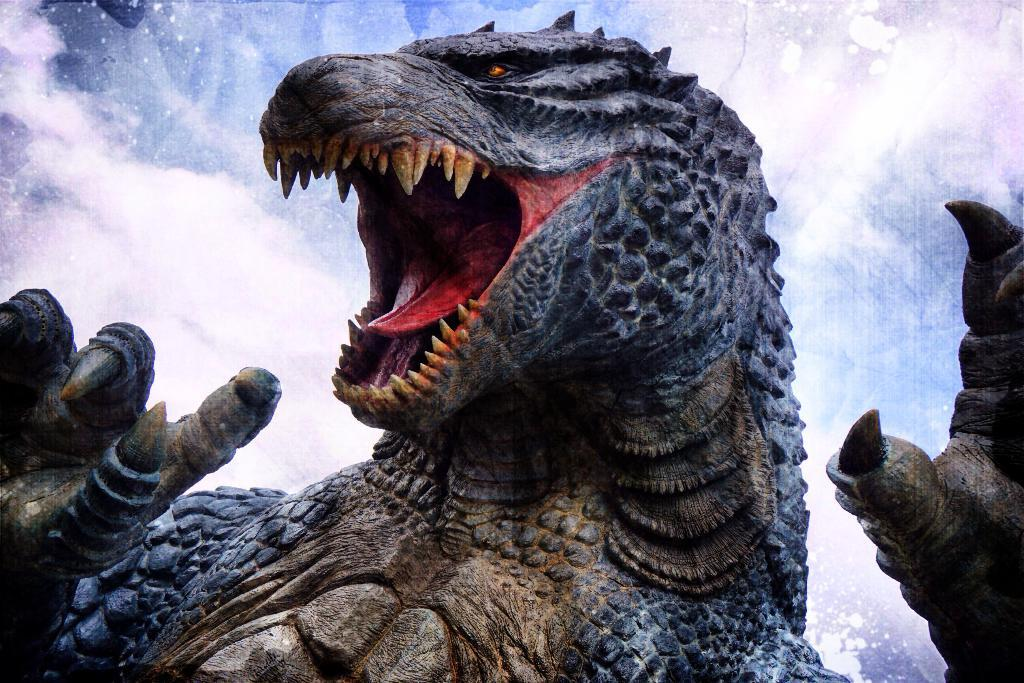What type of animal is in the image? There is a marine iguana in the image. What can be seen in the sky in the image? There are clouds in the sky in the image. What type of stick can be seen in the image? There is no stick present in the image. What date is marked on the calendar in the image? There is no calendar present in the image. 